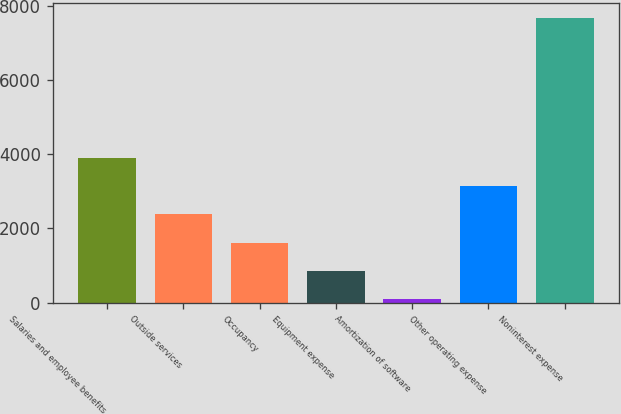<chart> <loc_0><loc_0><loc_500><loc_500><bar_chart><fcel>Salaries and employee benefits<fcel>Outside services<fcel>Occupancy<fcel>Equipment expense<fcel>Amortization of software<fcel>Other operating expense<fcel>Noninterest expense<nl><fcel>3890.5<fcel>2375.1<fcel>1617.4<fcel>859.7<fcel>102<fcel>3132.8<fcel>7679<nl></chart> 